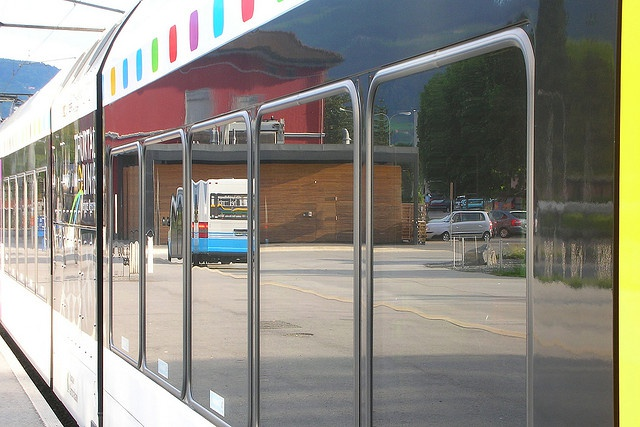Describe the objects in this image and their specific colors. I can see train in gray, darkgray, white, and black tones, bus in white, lightgray, gray, darkgray, and lightblue tones, car in white, gray, darkgray, and black tones, car in white, gray, black, maroon, and purple tones, and car in white, gray, black, darkgray, and lightgray tones in this image. 